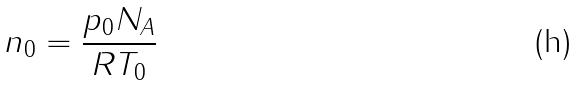<formula> <loc_0><loc_0><loc_500><loc_500>n _ { 0 } = \frac { p _ { 0 } N _ { A } } { R T _ { 0 } }</formula> 